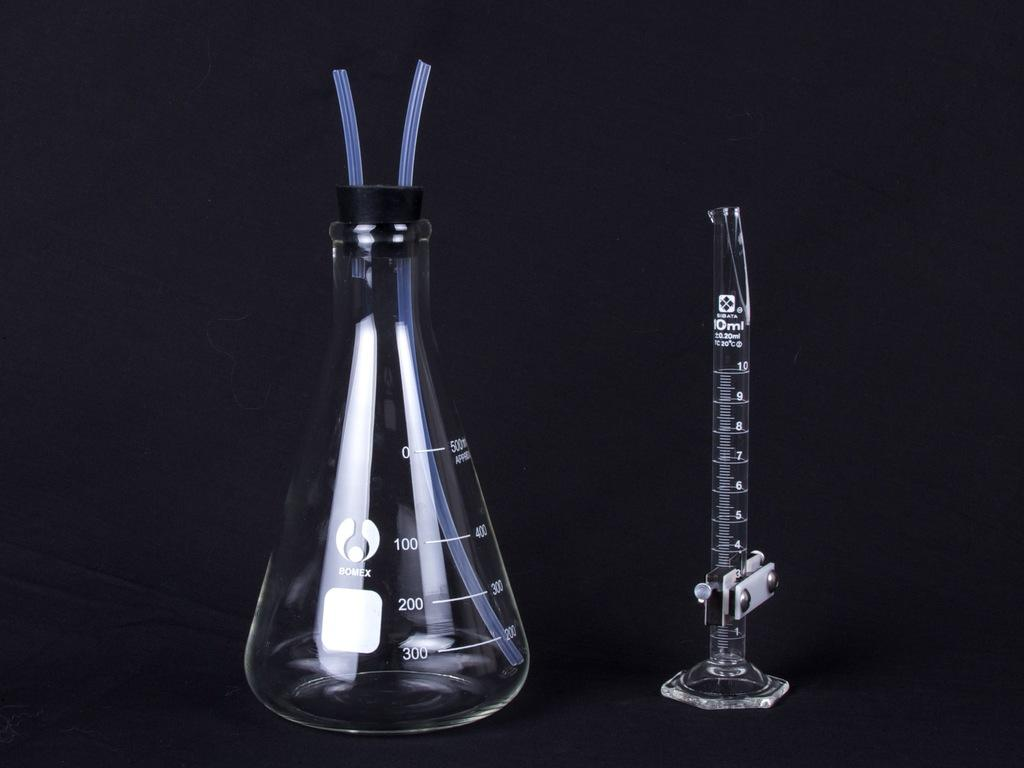<image>
Render a clear and concise summary of the photo. Two empty science beakers by Bomex sit against a black background 